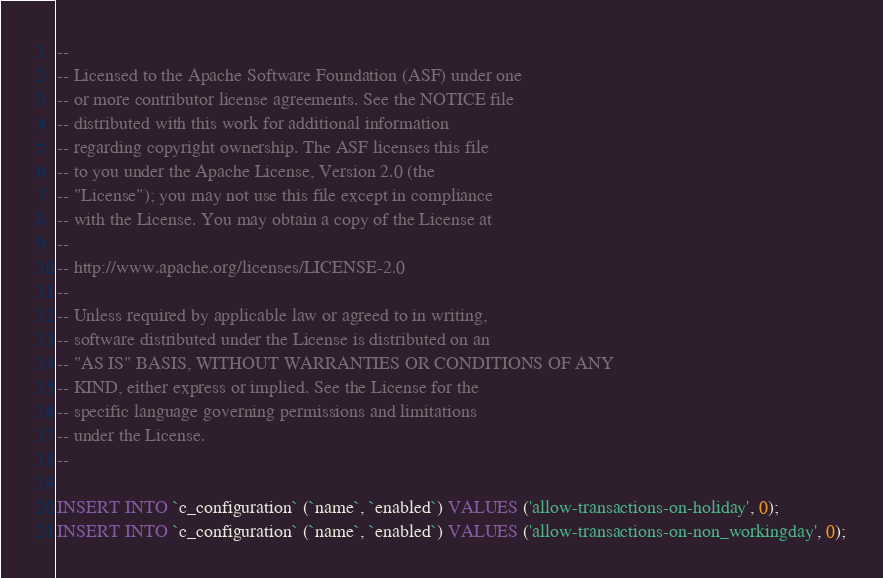<code> <loc_0><loc_0><loc_500><loc_500><_SQL_>--
-- Licensed to the Apache Software Foundation (ASF) under one
-- or more contributor license agreements. See the NOTICE file
-- distributed with this work for additional information
-- regarding copyright ownership. The ASF licenses this file
-- to you under the Apache License, Version 2.0 (the
-- "License"); you may not use this file except in compliance
-- with the License. You may obtain a copy of the License at
--
-- http://www.apache.org/licenses/LICENSE-2.0
--
-- Unless required by applicable law or agreed to in writing,
-- software distributed under the License is distributed on an
-- "AS IS" BASIS, WITHOUT WARRANTIES OR CONDITIONS OF ANY
-- KIND, either express or implied. See the License for the
-- specific language governing permissions and limitations
-- under the License.
--

INSERT INTO `c_configuration` (`name`, `enabled`) VALUES ('allow-transactions-on-holiday', 0);
INSERT INTO `c_configuration` (`name`, `enabled`) VALUES ('allow-transactions-on-non_workingday', 0);</code> 